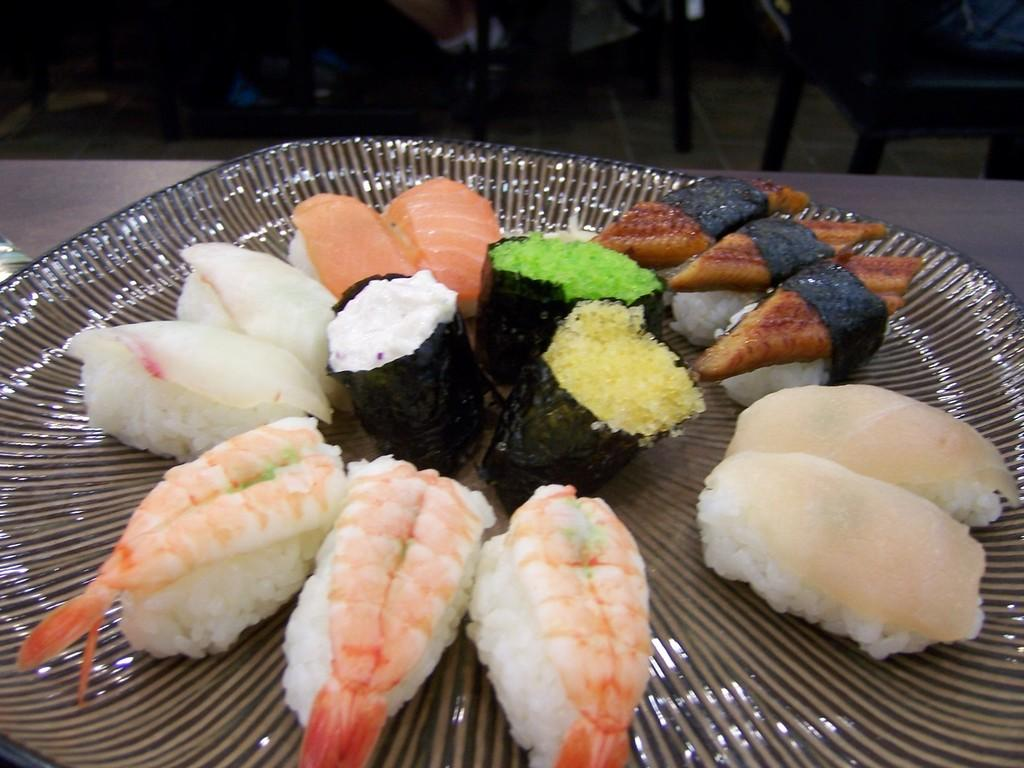What type of food is on the plate in the image? There is sushi on a plate in the image. Can you describe the variety of sushi on the plate? There are different types of sushi on the plate. What can be seen in the background of the image? There are chairs on the floor in the background of the image. Is there a boat visible in the image? No, there is no boat present in the image. Can you describe the force exerted by the sushi on the plate? The sushi is stationary on the plate, so there is no force being exerted. 